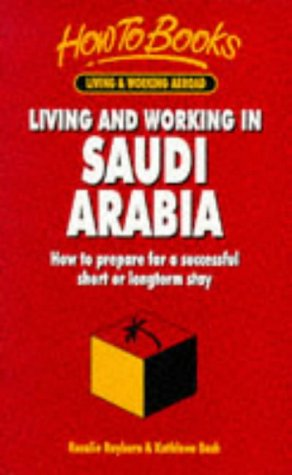Does the book discuss the legal aspects of living in Saudi Arabia? Yes, it likely covers essential legal aspects such as visa requirements, employment laws, and regulations one must follow as a foreign resident. Are there any sections on learning the Arabic language? While I cannot confirm specifics, most comprehensive guides like this include a section on language learning to help readers communicate effectively while living in a new country. 